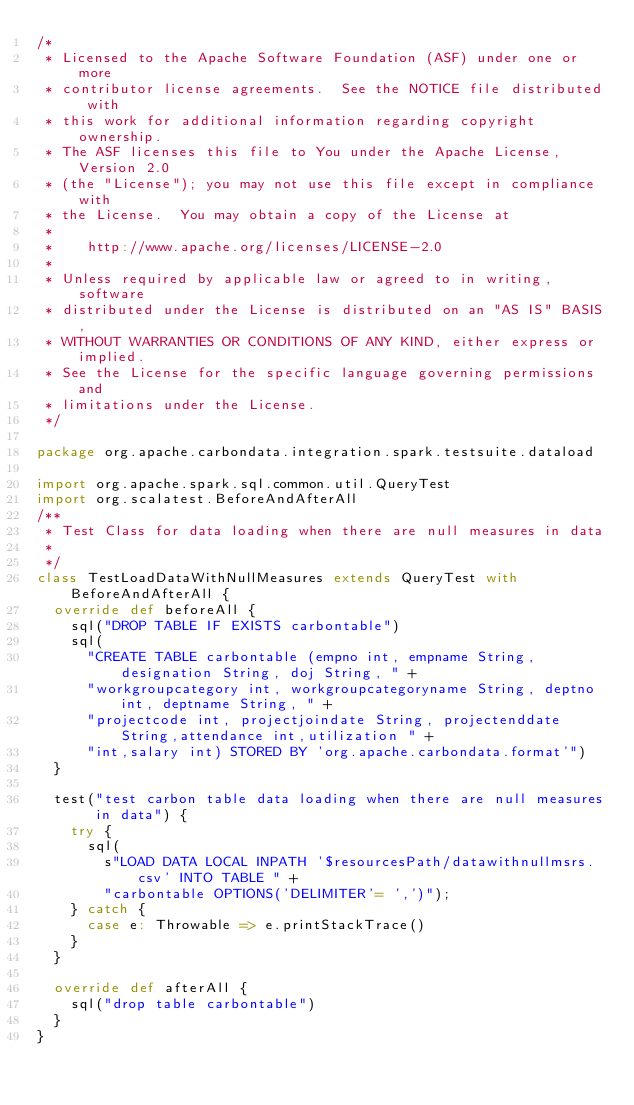Convert code to text. <code><loc_0><loc_0><loc_500><loc_500><_Scala_>/*
 * Licensed to the Apache Software Foundation (ASF) under one or more
 * contributor license agreements.  See the NOTICE file distributed with
 * this work for additional information regarding copyright ownership.
 * The ASF licenses this file to You under the Apache License, Version 2.0
 * (the "License"); you may not use this file except in compliance with
 * the License.  You may obtain a copy of the License at
 *
 *    http://www.apache.org/licenses/LICENSE-2.0
 *
 * Unless required by applicable law or agreed to in writing, software
 * distributed under the License is distributed on an "AS IS" BASIS,
 * WITHOUT WARRANTIES OR CONDITIONS OF ANY KIND, either express or implied.
 * See the License for the specific language governing permissions and
 * limitations under the License.
 */

package org.apache.carbondata.integration.spark.testsuite.dataload

import org.apache.spark.sql.common.util.QueryTest
import org.scalatest.BeforeAndAfterAll
/**
 * Test Class for data loading when there are null measures in data
 *
 */
class TestLoadDataWithNullMeasures extends QueryTest with BeforeAndAfterAll {
  override def beforeAll {
    sql("DROP TABLE IF EXISTS carbontable")
    sql(
      "CREATE TABLE carbontable (empno int, empname String, designation String, doj String, " +
      "workgroupcategory int, workgroupcategoryname String, deptno int, deptname String, " +
      "projectcode int, projectjoindate String, projectenddate String,attendance int,utilization " +
      "int,salary int) STORED BY 'org.apache.carbondata.format'")
  }

  test("test carbon table data loading when there are null measures in data") {
    try {
      sql(
        s"LOAD DATA LOCAL INPATH '$resourcesPath/datawithnullmsrs.csv' INTO TABLE " +
        "carbontable OPTIONS('DELIMITER'= ',')");
    } catch {
      case e: Throwable => e.printStackTrace()
    }
  }

  override def afterAll {
    sql("drop table carbontable")
  }
}
</code> 